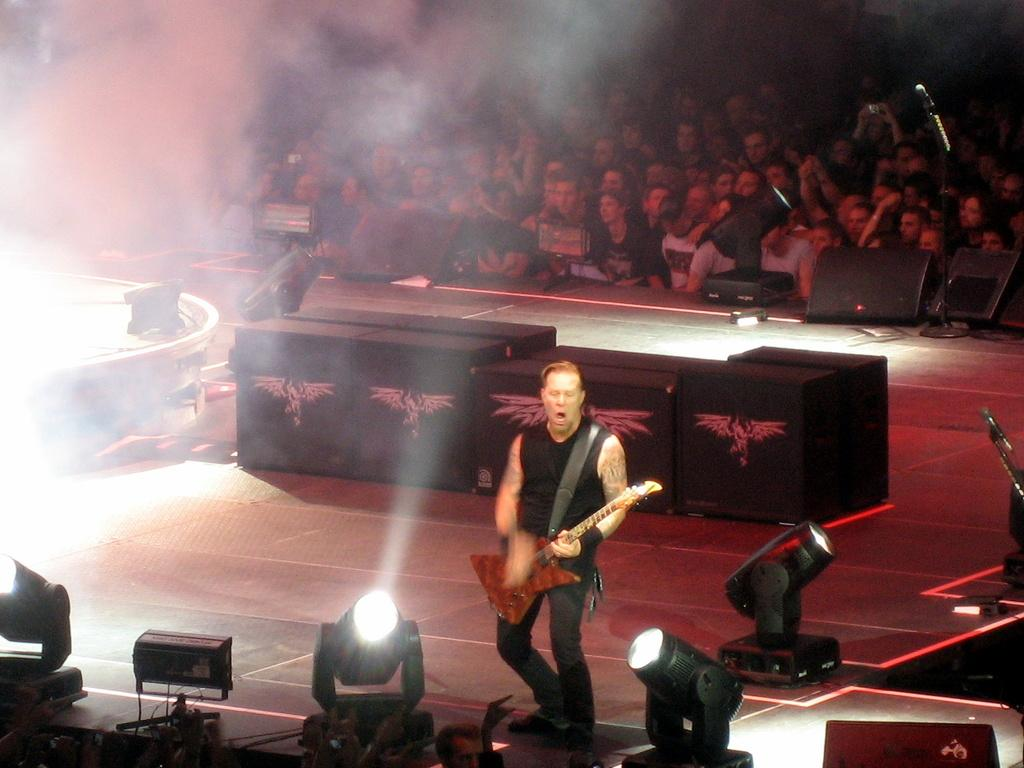Who is the main subject in the image? There is a man in the image. What is the man holding in the image? The man is holding a guitar. Where is the man located in the image? The man is on a stage. What can be seen in the background of the image? There are lights, smoke, and people visible in the background of the image. What type of soup is being served in the image? There is no soup present in the image. Can you see a goose in the image? There is no goose present in the image. 